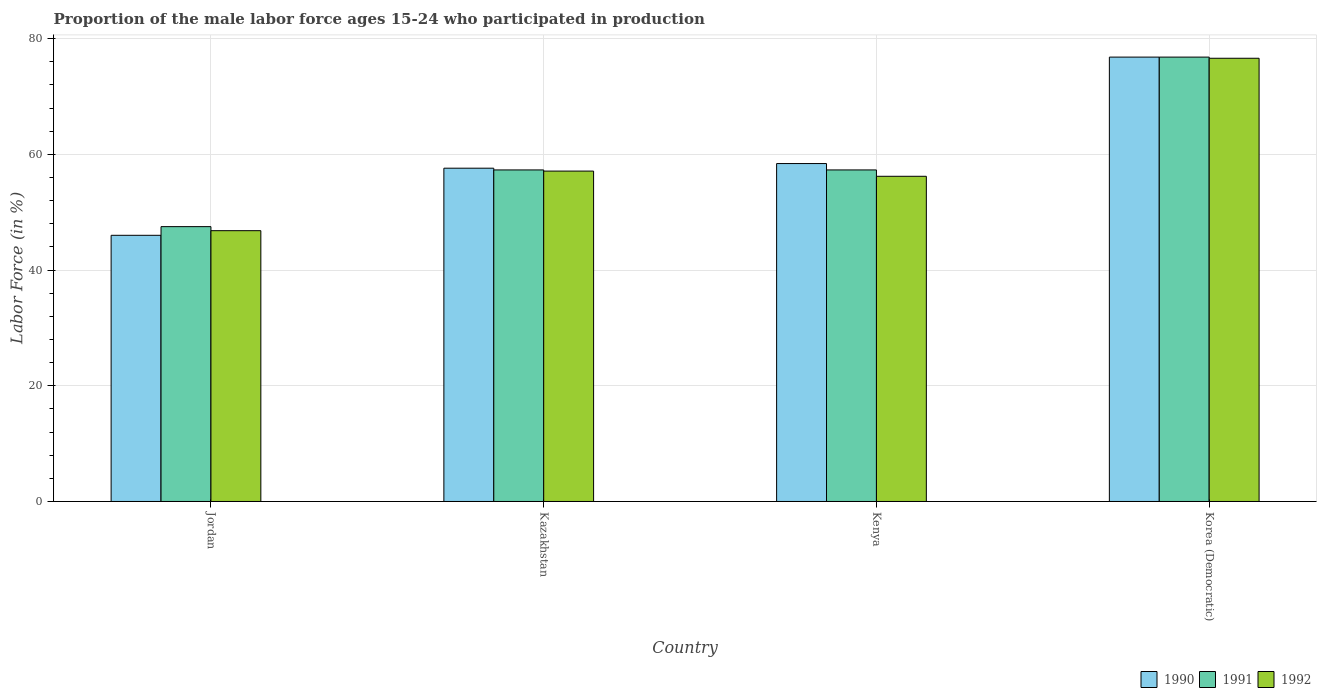Are the number of bars on each tick of the X-axis equal?
Your answer should be very brief. Yes. How many bars are there on the 2nd tick from the left?
Give a very brief answer. 3. What is the label of the 1st group of bars from the left?
Your answer should be very brief. Jordan. Across all countries, what is the maximum proportion of the male labor force who participated in production in 1990?
Your response must be concise. 76.8. Across all countries, what is the minimum proportion of the male labor force who participated in production in 1990?
Offer a terse response. 46. In which country was the proportion of the male labor force who participated in production in 1991 maximum?
Your response must be concise. Korea (Democratic). In which country was the proportion of the male labor force who participated in production in 1992 minimum?
Make the answer very short. Jordan. What is the total proportion of the male labor force who participated in production in 1991 in the graph?
Your response must be concise. 238.9. What is the difference between the proportion of the male labor force who participated in production in 1992 in Jordan and that in Kazakhstan?
Ensure brevity in your answer.  -10.3. What is the difference between the proportion of the male labor force who participated in production in 1991 in Korea (Democratic) and the proportion of the male labor force who participated in production in 1992 in Kazakhstan?
Keep it short and to the point. 19.7. What is the average proportion of the male labor force who participated in production in 1990 per country?
Offer a terse response. 59.7. What is the difference between the proportion of the male labor force who participated in production of/in 1992 and proportion of the male labor force who participated in production of/in 1991 in Korea (Democratic)?
Your answer should be very brief. -0.2. In how many countries, is the proportion of the male labor force who participated in production in 1990 greater than 40 %?
Provide a succinct answer. 4. What is the ratio of the proportion of the male labor force who participated in production in 1991 in Kazakhstan to that in Kenya?
Give a very brief answer. 1. Is the proportion of the male labor force who participated in production in 1991 in Kenya less than that in Korea (Democratic)?
Ensure brevity in your answer.  Yes. What is the difference between the highest and the second highest proportion of the male labor force who participated in production in 1990?
Provide a short and direct response. -0.8. What is the difference between the highest and the lowest proportion of the male labor force who participated in production in 1990?
Provide a short and direct response. 30.8. In how many countries, is the proportion of the male labor force who participated in production in 1990 greater than the average proportion of the male labor force who participated in production in 1990 taken over all countries?
Give a very brief answer. 1. What does the 1st bar from the left in Jordan represents?
Your response must be concise. 1990. Is it the case that in every country, the sum of the proportion of the male labor force who participated in production in 1992 and proportion of the male labor force who participated in production in 1990 is greater than the proportion of the male labor force who participated in production in 1991?
Give a very brief answer. Yes. Are all the bars in the graph horizontal?
Your answer should be very brief. No. How many countries are there in the graph?
Ensure brevity in your answer.  4. What is the difference between two consecutive major ticks on the Y-axis?
Offer a very short reply. 20. Are the values on the major ticks of Y-axis written in scientific E-notation?
Ensure brevity in your answer.  No. Does the graph contain grids?
Provide a short and direct response. Yes. Where does the legend appear in the graph?
Provide a short and direct response. Bottom right. How are the legend labels stacked?
Offer a terse response. Horizontal. What is the title of the graph?
Your answer should be compact. Proportion of the male labor force ages 15-24 who participated in production. Does "1976" appear as one of the legend labels in the graph?
Provide a short and direct response. No. What is the label or title of the X-axis?
Ensure brevity in your answer.  Country. What is the Labor Force (in %) in 1991 in Jordan?
Offer a terse response. 47.5. What is the Labor Force (in %) in 1992 in Jordan?
Keep it short and to the point. 46.8. What is the Labor Force (in %) in 1990 in Kazakhstan?
Your response must be concise. 57.6. What is the Labor Force (in %) in 1991 in Kazakhstan?
Offer a very short reply. 57.3. What is the Labor Force (in %) in 1992 in Kazakhstan?
Your answer should be very brief. 57.1. What is the Labor Force (in %) of 1990 in Kenya?
Give a very brief answer. 58.4. What is the Labor Force (in %) of 1991 in Kenya?
Make the answer very short. 57.3. What is the Labor Force (in %) of 1992 in Kenya?
Your answer should be very brief. 56.2. What is the Labor Force (in %) of 1990 in Korea (Democratic)?
Give a very brief answer. 76.8. What is the Labor Force (in %) of 1991 in Korea (Democratic)?
Make the answer very short. 76.8. What is the Labor Force (in %) in 1992 in Korea (Democratic)?
Ensure brevity in your answer.  76.6. Across all countries, what is the maximum Labor Force (in %) of 1990?
Provide a short and direct response. 76.8. Across all countries, what is the maximum Labor Force (in %) of 1991?
Keep it short and to the point. 76.8. Across all countries, what is the maximum Labor Force (in %) in 1992?
Your answer should be very brief. 76.6. Across all countries, what is the minimum Labor Force (in %) of 1991?
Make the answer very short. 47.5. Across all countries, what is the minimum Labor Force (in %) of 1992?
Ensure brevity in your answer.  46.8. What is the total Labor Force (in %) of 1990 in the graph?
Provide a short and direct response. 238.8. What is the total Labor Force (in %) in 1991 in the graph?
Your response must be concise. 238.9. What is the total Labor Force (in %) in 1992 in the graph?
Give a very brief answer. 236.7. What is the difference between the Labor Force (in %) of 1990 in Jordan and that in Kazakhstan?
Your response must be concise. -11.6. What is the difference between the Labor Force (in %) in 1991 in Jordan and that in Kazakhstan?
Your response must be concise. -9.8. What is the difference between the Labor Force (in %) of 1992 in Jordan and that in Kazakhstan?
Offer a very short reply. -10.3. What is the difference between the Labor Force (in %) in 1991 in Jordan and that in Kenya?
Your answer should be compact. -9.8. What is the difference between the Labor Force (in %) in 1992 in Jordan and that in Kenya?
Keep it short and to the point. -9.4. What is the difference between the Labor Force (in %) of 1990 in Jordan and that in Korea (Democratic)?
Keep it short and to the point. -30.8. What is the difference between the Labor Force (in %) of 1991 in Jordan and that in Korea (Democratic)?
Ensure brevity in your answer.  -29.3. What is the difference between the Labor Force (in %) in 1992 in Jordan and that in Korea (Democratic)?
Give a very brief answer. -29.8. What is the difference between the Labor Force (in %) of 1990 in Kazakhstan and that in Kenya?
Give a very brief answer. -0.8. What is the difference between the Labor Force (in %) of 1990 in Kazakhstan and that in Korea (Democratic)?
Offer a very short reply. -19.2. What is the difference between the Labor Force (in %) in 1991 in Kazakhstan and that in Korea (Democratic)?
Keep it short and to the point. -19.5. What is the difference between the Labor Force (in %) in 1992 in Kazakhstan and that in Korea (Democratic)?
Provide a succinct answer. -19.5. What is the difference between the Labor Force (in %) in 1990 in Kenya and that in Korea (Democratic)?
Offer a terse response. -18.4. What is the difference between the Labor Force (in %) of 1991 in Kenya and that in Korea (Democratic)?
Provide a short and direct response. -19.5. What is the difference between the Labor Force (in %) in 1992 in Kenya and that in Korea (Democratic)?
Your answer should be very brief. -20.4. What is the difference between the Labor Force (in %) of 1990 in Jordan and the Labor Force (in %) of 1991 in Kazakhstan?
Provide a short and direct response. -11.3. What is the difference between the Labor Force (in %) of 1990 in Jordan and the Labor Force (in %) of 1991 in Kenya?
Your answer should be compact. -11.3. What is the difference between the Labor Force (in %) in 1990 in Jordan and the Labor Force (in %) in 1991 in Korea (Democratic)?
Provide a short and direct response. -30.8. What is the difference between the Labor Force (in %) of 1990 in Jordan and the Labor Force (in %) of 1992 in Korea (Democratic)?
Your answer should be very brief. -30.6. What is the difference between the Labor Force (in %) of 1991 in Jordan and the Labor Force (in %) of 1992 in Korea (Democratic)?
Offer a terse response. -29.1. What is the difference between the Labor Force (in %) in 1990 in Kazakhstan and the Labor Force (in %) in 1991 in Korea (Democratic)?
Provide a short and direct response. -19.2. What is the difference between the Labor Force (in %) in 1991 in Kazakhstan and the Labor Force (in %) in 1992 in Korea (Democratic)?
Ensure brevity in your answer.  -19.3. What is the difference between the Labor Force (in %) in 1990 in Kenya and the Labor Force (in %) in 1991 in Korea (Democratic)?
Your response must be concise. -18.4. What is the difference between the Labor Force (in %) in 1990 in Kenya and the Labor Force (in %) in 1992 in Korea (Democratic)?
Ensure brevity in your answer.  -18.2. What is the difference between the Labor Force (in %) in 1991 in Kenya and the Labor Force (in %) in 1992 in Korea (Democratic)?
Offer a terse response. -19.3. What is the average Labor Force (in %) in 1990 per country?
Give a very brief answer. 59.7. What is the average Labor Force (in %) of 1991 per country?
Your response must be concise. 59.73. What is the average Labor Force (in %) of 1992 per country?
Your answer should be very brief. 59.17. What is the difference between the Labor Force (in %) in 1990 and Labor Force (in %) in 1991 in Jordan?
Your answer should be compact. -1.5. What is the difference between the Labor Force (in %) in 1990 and Labor Force (in %) in 1992 in Jordan?
Your answer should be very brief. -0.8. What is the difference between the Labor Force (in %) of 1991 and Labor Force (in %) of 1992 in Jordan?
Make the answer very short. 0.7. What is the difference between the Labor Force (in %) of 1990 and Labor Force (in %) of 1991 in Kazakhstan?
Give a very brief answer. 0.3. What is the difference between the Labor Force (in %) of 1991 and Labor Force (in %) of 1992 in Kazakhstan?
Provide a short and direct response. 0.2. What is the difference between the Labor Force (in %) in 1991 and Labor Force (in %) in 1992 in Kenya?
Your answer should be very brief. 1.1. What is the difference between the Labor Force (in %) in 1990 and Labor Force (in %) in 1992 in Korea (Democratic)?
Your response must be concise. 0.2. What is the ratio of the Labor Force (in %) of 1990 in Jordan to that in Kazakhstan?
Ensure brevity in your answer.  0.8. What is the ratio of the Labor Force (in %) in 1991 in Jordan to that in Kazakhstan?
Give a very brief answer. 0.83. What is the ratio of the Labor Force (in %) of 1992 in Jordan to that in Kazakhstan?
Your response must be concise. 0.82. What is the ratio of the Labor Force (in %) in 1990 in Jordan to that in Kenya?
Offer a terse response. 0.79. What is the ratio of the Labor Force (in %) of 1991 in Jordan to that in Kenya?
Your answer should be very brief. 0.83. What is the ratio of the Labor Force (in %) in 1992 in Jordan to that in Kenya?
Your answer should be very brief. 0.83. What is the ratio of the Labor Force (in %) in 1990 in Jordan to that in Korea (Democratic)?
Offer a very short reply. 0.6. What is the ratio of the Labor Force (in %) of 1991 in Jordan to that in Korea (Democratic)?
Provide a short and direct response. 0.62. What is the ratio of the Labor Force (in %) in 1992 in Jordan to that in Korea (Democratic)?
Make the answer very short. 0.61. What is the ratio of the Labor Force (in %) of 1990 in Kazakhstan to that in Kenya?
Provide a succinct answer. 0.99. What is the ratio of the Labor Force (in %) in 1991 in Kazakhstan to that in Kenya?
Your answer should be very brief. 1. What is the ratio of the Labor Force (in %) of 1991 in Kazakhstan to that in Korea (Democratic)?
Keep it short and to the point. 0.75. What is the ratio of the Labor Force (in %) of 1992 in Kazakhstan to that in Korea (Democratic)?
Your response must be concise. 0.75. What is the ratio of the Labor Force (in %) in 1990 in Kenya to that in Korea (Democratic)?
Ensure brevity in your answer.  0.76. What is the ratio of the Labor Force (in %) of 1991 in Kenya to that in Korea (Democratic)?
Give a very brief answer. 0.75. What is the ratio of the Labor Force (in %) of 1992 in Kenya to that in Korea (Democratic)?
Give a very brief answer. 0.73. What is the difference between the highest and the second highest Labor Force (in %) in 1990?
Provide a succinct answer. 18.4. What is the difference between the highest and the second highest Labor Force (in %) in 1992?
Make the answer very short. 19.5. What is the difference between the highest and the lowest Labor Force (in %) of 1990?
Offer a very short reply. 30.8. What is the difference between the highest and the lowest Labor Force (in %) of 1991?
Keep it short and to the point. 29.3. What is the difference between the highest and the lowest Labor Force (in %) of 1992?
Your answer should be very brief. 29.8. 